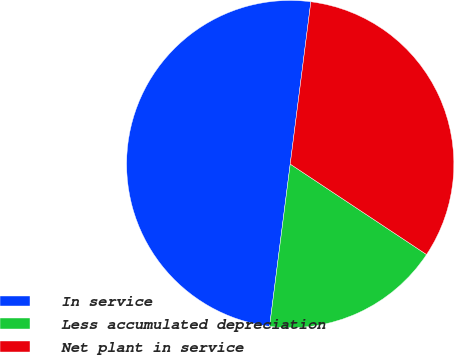Convert chart. <chart><loc_0><loc_0><loc_500><loc_500><pie_chart><fcel>In service<fcel>Less accumulated depreciation<fcel>Net plant in service<nl><fcel>50.0%<fcel>17.69%<fcel>32.31%<nl></chart> 